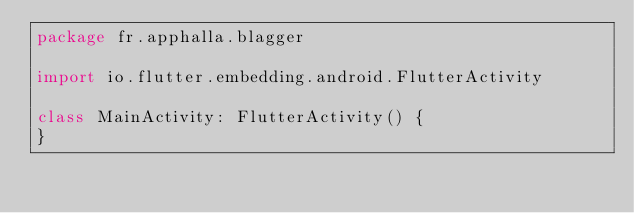<code> <loc_0><loc_0><loc_500><loc_500><_Kotlin_>package fr.apphalla.blagger

import io.flutter.embedding.android.FlutterActivity

class MainActivity: FlutterActivity() {
}
</code> 